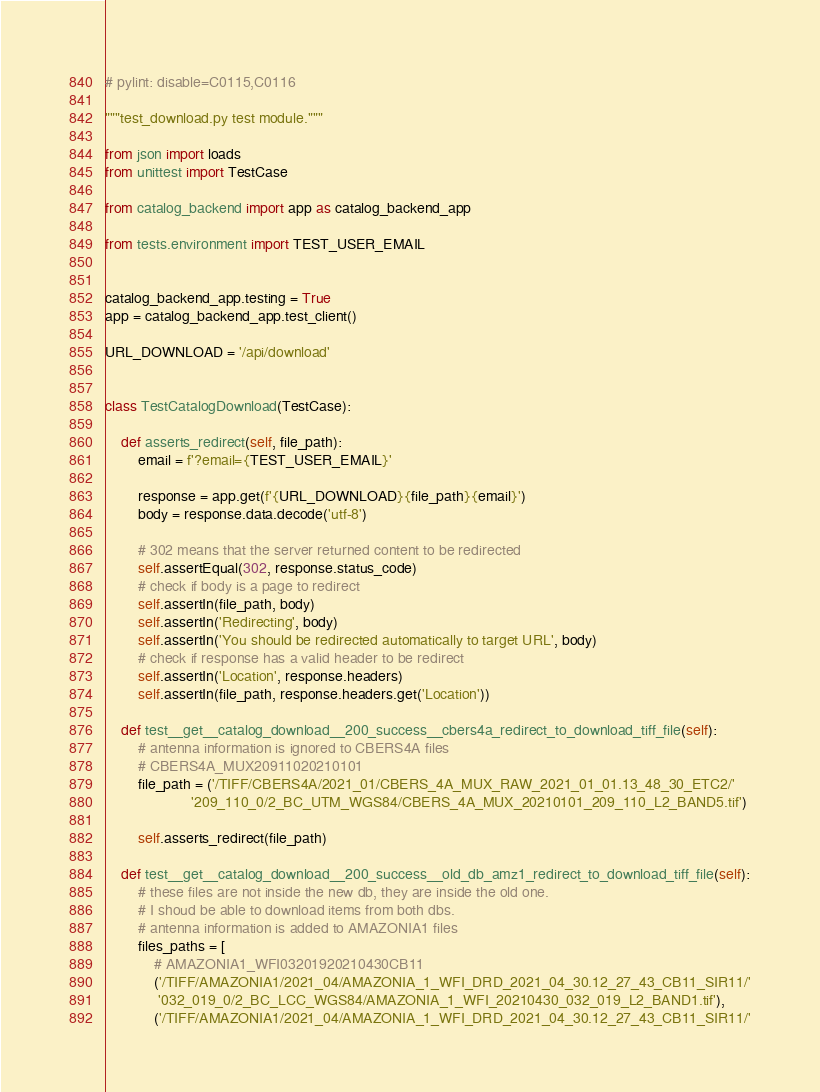Convert code to text. <code><loc_0><loc_0><loc_500><loc_500><_Python_># pylint: disable=C0115,C0116

"""test_download.py test module."""

from json import loads
from unittest import TestCase

from catalog_backend import app as catalog_backend_app

from tests.environment import TEST_USER_EMAIL


catalog_backend_app.testing = True
app = catalog_backend_app.test_client()

URL_DOWNLOAD = '/api/download'


class TestCatalogDownload(TestCase):

    def asserts_redirect(self, file_path):
        email = f'?email={TEST_USER_EMAIL}'

        response = app.get(f'{URL_DOWNLOAD}{file_path}{email}')
        body = response.data.decode('utf-8')

        # 302 means that the server returned content to be redirected
        self.assertEqual(302, response.status_code)
        # check if body is a page to redirect
        self.assertIn(file_path, body)
        self.assertIn('Redirecting', body)
        self.assertIn('You should be redirected automatically to target URL', body)
        # check if response has a valid header to be redirect
        self.assertIn('Location', response.headers)
        self.assertIn(file_path, response.headers.get('Location'))

    def test__get__catalog_download__200_success__cbers4a_redirect_to_download_tiff_file(self):
        # antenna information is ignored to CBERS4A files
        # CBERS4A_MUX20911020210101
        file_path = ('/TIFF/CBERS4A/2021_01/CBERS_4A_MUX_RAW_2021_01_01.13_48_30_ETC2/'
                     '209_110_0/2_BC_UTM_WGS84/CBERS_4A_MUX_20210101_209_110_L2_BAND5.tif')

        self.asserts_redirect(file_path)

    def test__get__catalog_download__200_success__old_db_amz1_redirect_to_download_tiff_file(self):
        # these files are not inside the new db, they are inside the old one.
        # I shoud be able to download items from both dbs.
        # antenna information is added to AMAZONIA1 files
        files_paths = [
            # AMAZONIA1_WFI03201920210430CB11
            ('/TIFF/AMAZONIA1/2021_04/AMAZONIA_1_WFI_DRD_2021_04_30.12_27_43_CB11_SIR11/'
             '032_019_0/2_BC_LCC_WGS84/AMAZONIA_1_WFI_20210430_032_019_L2_BAND1.tif'),
            ('/TIFF/AMAZONIA1/2021_04/AMAZONIA_1_WFI_DRD_2021_04_30.12_27_43_CB11_SIR11/'</code> 